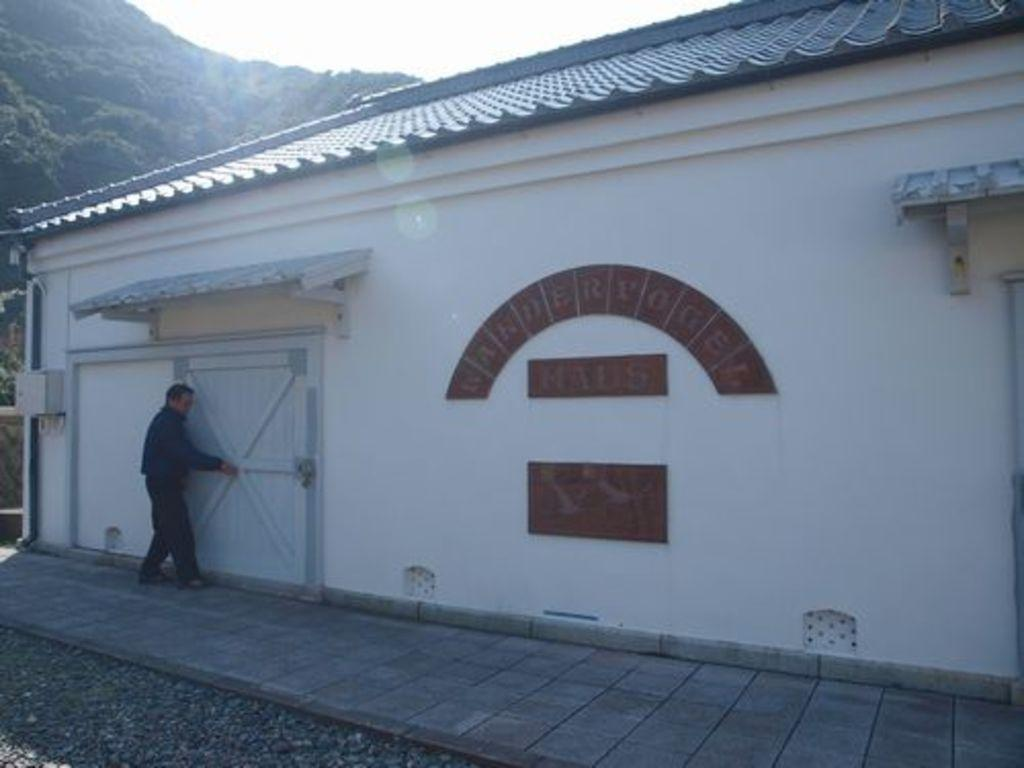What type of structure is in the image? There is a building in the image. Can you describe the person's location in relation to the building? The person is near the door of the building. What type of vegetation is in the image? There are trees in the image. What is visible in the background of the image? The sky is visible in the image. What type of flooring is present in the image? There is a wooden floor in the image. What type of material is present in the image besides the wooden floor? Stones are present in the image. What type of umbrella is the person holding in the image? There is no umbrella present in the image. Is the person playing baseball in the image? There is no baseball activity depicted in the image. What type of floor is visible under the stones in the image? The provided facts do not mention a floor under the stones, so it cannot be determined from the image. 